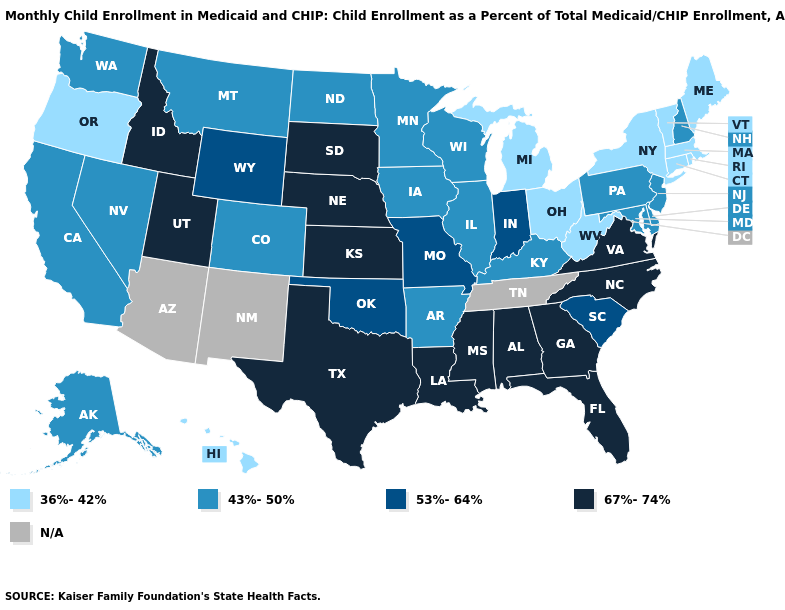What is the highest value in the West ?
Be succinct. 67%-74%. What is the value of Montana?
Keep it brief. 43%-50%. Does the first symbol in the legend represent the smallest category?
Quick response, please. Yes. What is the lowest value in states that border Virginia?
Write a very short answer. 36%-42%. Name the states that have a value in the range 36%-42%?
Short answer required. Connecticut, Hawaii, Maine, Massachusetts, Michigan, New York, Ohio, Oregon, Rhode Island, Vermont, West Virginia. What is the value of North Dakota?
Quick response, please. 43%-50%. What is the value of Alabama?
Be succinct. 67%-74%. Among the states that border California , which have the highest value?
Keep it brief. Nevada. What is the value of Indiana?
Concise answer only. 53%-64%. Does the map have missing data?
Concise answer only. Yes. What is the value of Wisconsin?
Answer briefly. 43%-50%. Does Michigan have the highest value in the USA?
Short answer required. No. Among the states that border Kansas , does Nebraska have the lowest value?
Keep it brief. No. Among the states that border Vermont , which have the highest value?
Be succinct. New Hampshire. 